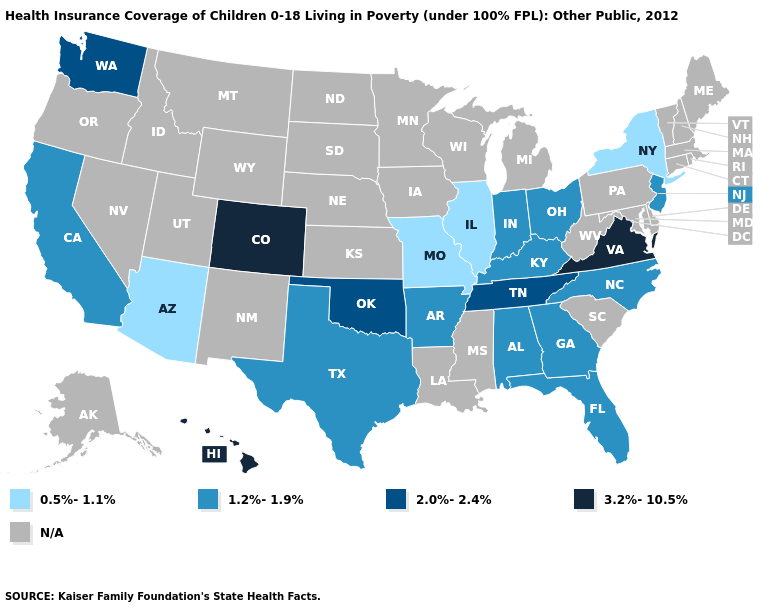Does the map have missing data?
Write a very short answer. Yes. Name the states that have a value in the range 1.2%-1.9%?
Be succinct. Alabama, Arkansas, California, Florida, Georgia, Indiana, Kentucky, New Jersey, North Carolina, Ohio, Texas. What is the value of Colorado?
Give a very brief answer. 3.2%-10.5%. Does the map have missing data?
Give a very brief answer. Yes. What is the value of Alabama?
Write a very short answer. 1.2%-1.9%. Name the states that have a value in the range 0.5%-1.1%?
Short answer required. Arizona, Illinois, Missouri, New York. Does Arkansas have the lowest value in the South?
Answer briefly. Yes. Does New Jersey have the highest value in the Northeast?
Be succinct. Yes. Name the states that have a value in the range 0.5%-1.1%?
Write a very short answer. Arizona, Illinois, Missouri, New York. Does Alabama have the highest value in the USA?
Concise answer only. No. Which states have the highest value in the USA?
Concise answer only. Colorado, Hawaii, Virginia. Does the map have missing data?
Give a very brief answer. Yes. 